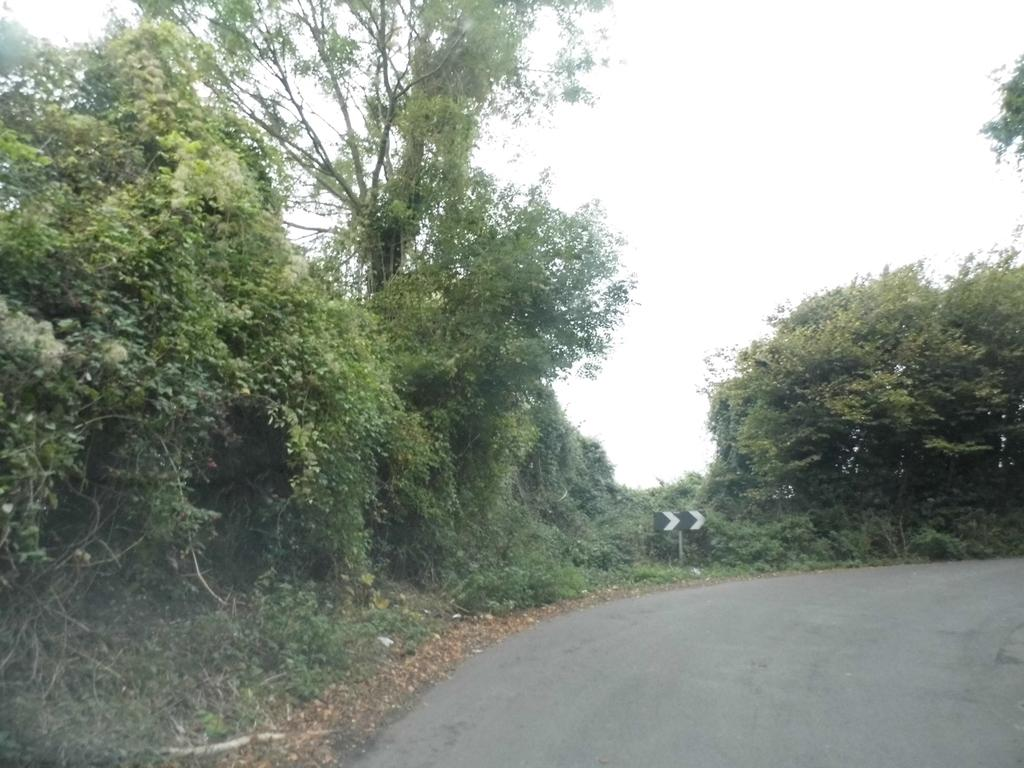What is the main feature of the image? There is a road in the image. What can be seen in the background of the image? There are trees and the sky visible in the background of the image. What historical event is being reenacted on the road in the image? There is no historical event being reenacted in the image; it simply shows a road with trees and the sky in the background. 